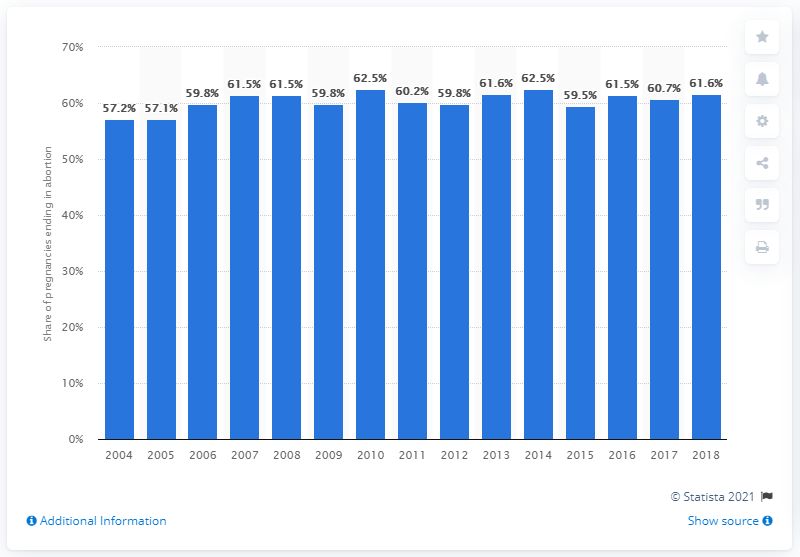Highlight a few significant elements in this photo. In 2018, 61.6% of pregnancies ended in abortion. 